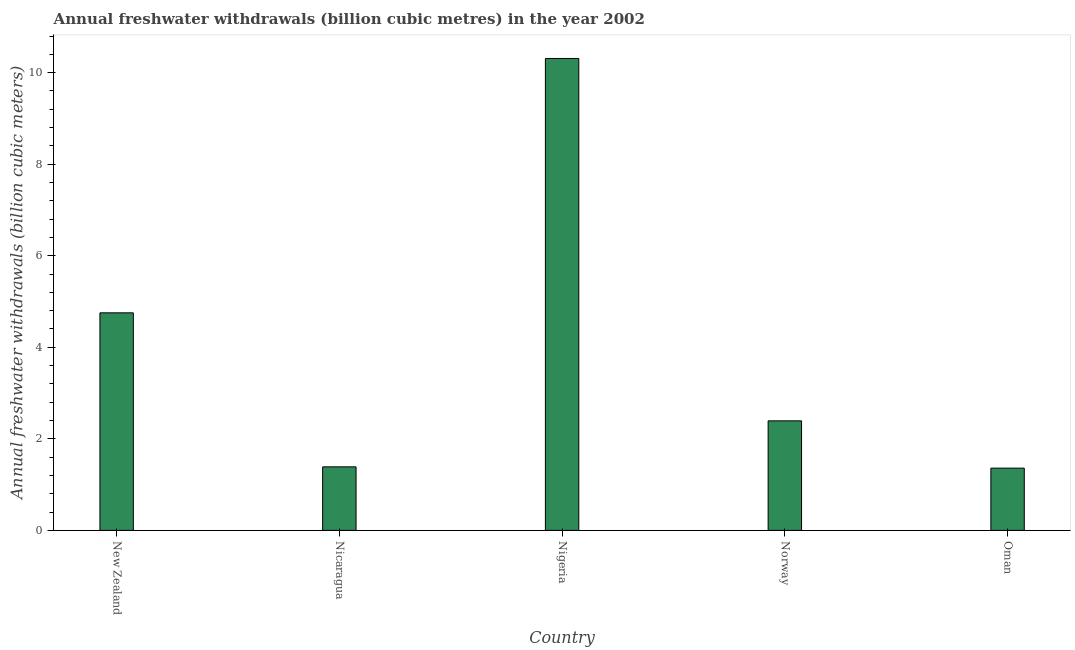Does the graph contain grids?
Your answer should be compact. No. What is the title of the graph?
Keep it short and to the point. Annual freshwater withdrawals (billion cubic metres) in the year 2002. What is the label or title of the Y-axis?
Give a very brief answer. Annual freshwater withdrawals (billion cubic meters). What is the annual freshwater withdrawals in New Zealand?
Give a very brief answer. 4.75. Across all countries, what is the maximum annual freshwater withdrawals?
Provide a succinct answer. 10.31. Across all countries, what is the minimum annual freshwater withdrawals?
Offer a very short reply. 1.36. In which country was the annual freshwater withdrawals maximum?
Make the answer very short. Nigeria. In which country was the annual freshwater withdrawals minimum?
Offer a terse response. Oman. What is the sum of the annual freshwater withdrawals?
Give a very brief answer. 20.2. What is the difference between the annual freshwater withdrawals in Nicaragua and Norway?
Offer a terse response. -1. What is the average annual freshwater withdrawals per country?
Your answer should be very brief. 4.04. What is the median annual freshwater withdrawals?
Provide a short and direct response. 2.39. In how many countries, is the annual freshwater withdrawals greater than 6.8 billion cubic meters?
Your answer should be very brief. 1. What is the ratio of the annual freshwater withdrawals in New Zealand to that in Nicaragua?
Your answer should be compact. 3.42. What is the difference between the highest and the second highest annual freshwater withdrawals?
Offer a very short reply. 5.56. Is the sum of the annual freshwater withdrawals in Nigeria and Norway greater than the maximum annual freshwater withdrawals across all countries?
Ensure brevity in your answer.  Yes. What is the difference between the highest and the lowest annual freshwater withdrawals?
Offer a very short reply. 8.95. In how many countries, is the annual freshwater withdrawals greater than the average annual freshwater withdrawals taken over all countries?
Your answer should be very brief. 2. Are all the bars in the graph horizontal?
Ensure brevity in your answer.  No. What is the difference between two consecutive major ticks on the Y-axis?
Keep it short and to the point. 2. Are the values on the major ticks of Y-axis written in scientific E-notation?
Your answer should be compact. No. What is the Annual freshwater withdrawals (billion cubic meters) of New Zealand?
Provide a short and direct response. 4.75. What is the Annual freshwater withdrawals (billion cubic meters) of Nicaragua?
Your answer should be compact. 1.39. What is the Annual freshwater withdrawals (billion cubic meters) in Nigeria?
Give a very brief answer. 10.31. What is the Annual freshwater withdrawals (billion cubic meters) of Norway?
Ensure brevity in your answer.  2.39. What is the Annual freshwater withdrawals (billion cubic meters) in Oman?
Make the answer very short. 1.36. What is the difference between the Annual freshwater withdrawals (billion cubic meters) in New Zealand and Nicaragua?
Offer a terse response. 3.37. What is the difference between the Annual freshwater withdrawals (billion cubic meters) in New Zealand and Nigeria?
Your answer should be very brief. -5.56. What is the difference between the Annual freshwater withdrawals (billion cubic meters) in New Zealand and Norway?
Keep it short and to the point. 2.36. What is the difference between the Annual freshwater withdrawals (billion cubic meters) in New Zealand and Oman?
Your answer should be compact. 3.39. What is the difference between the Annual freshwater withdrawals (billion cubic meters) in Nicaragua and Nigeria?
Keep it short and to the point. -8.92. What is the difference between the Annual freshwater withdrawals (billion cubic meters) in Nicaragua and Norway?
Offer a very short reply. -1. What is the difference between the Annual freshwater withdrawals (billion cubic meters) in Nicaragua and Oman?
Provide a succinct answer. 0.03. What is the difference between the Annual freshwater withdrawals (billion cubic meters) in Nigeria and Norway?
Provide a short and direct response. 7.92. What is the difference between the Annual freshwater withdrawals (billion cubic meters) in Nigeria and Oman?
Keep it short and to the point. 8.95. What is the difference between the Annual freshwater withdrawals (billion cubic meters) in Norway and Oman?
Ensure brevity in your answer.  1.03. What is the ratio of the Annual freshwater withdrawals (billion cubic meters) in New Zealand to that in Nicaragua?
Give a very brief answer. 3.42. What is the ratio of the Annual freshwater withdrawals (billion cubic meters) in New Zealand to that in Nigeria?
Keep it short and to the point. 0.46. What is the ratio of the Annual freshwater withdrawals (billion cubic meters) in New Zealand to that in Norway?
Your answer should be compact. 1.99. What is the ratio of the Annual freshwater withdrawals (billion cubic meters) in New Zealand to that in Oman?
Your answer should be compact. 3.5. What is the ratio of the Annual freshwater withdrawals (billion cubic meters) in Nicaragua to that in Nigeria?
Make the answer very short. 0.14. What is the ratio of the Annual freshwater withdrawals (billion cubic meters) in Nicaragua to that in Norway?
Provide a short and direct response. 0.58. What is the ratio of the Annual freshwater withdrawals (billion cubic meters) in Nigeria to that in Norway?
Offer a terse response. 4.31. What is the ratio of the Annual freshwater withdrawals (billion cubic meters) in Nigeria to that in Oman?
Provide a succinct answer. 7.58. What is the ratio of the Annual freshwater withdrawals (billion cubic meters) in Norway to that in Oman?
Ensure brevity in your answer.  1.76. 